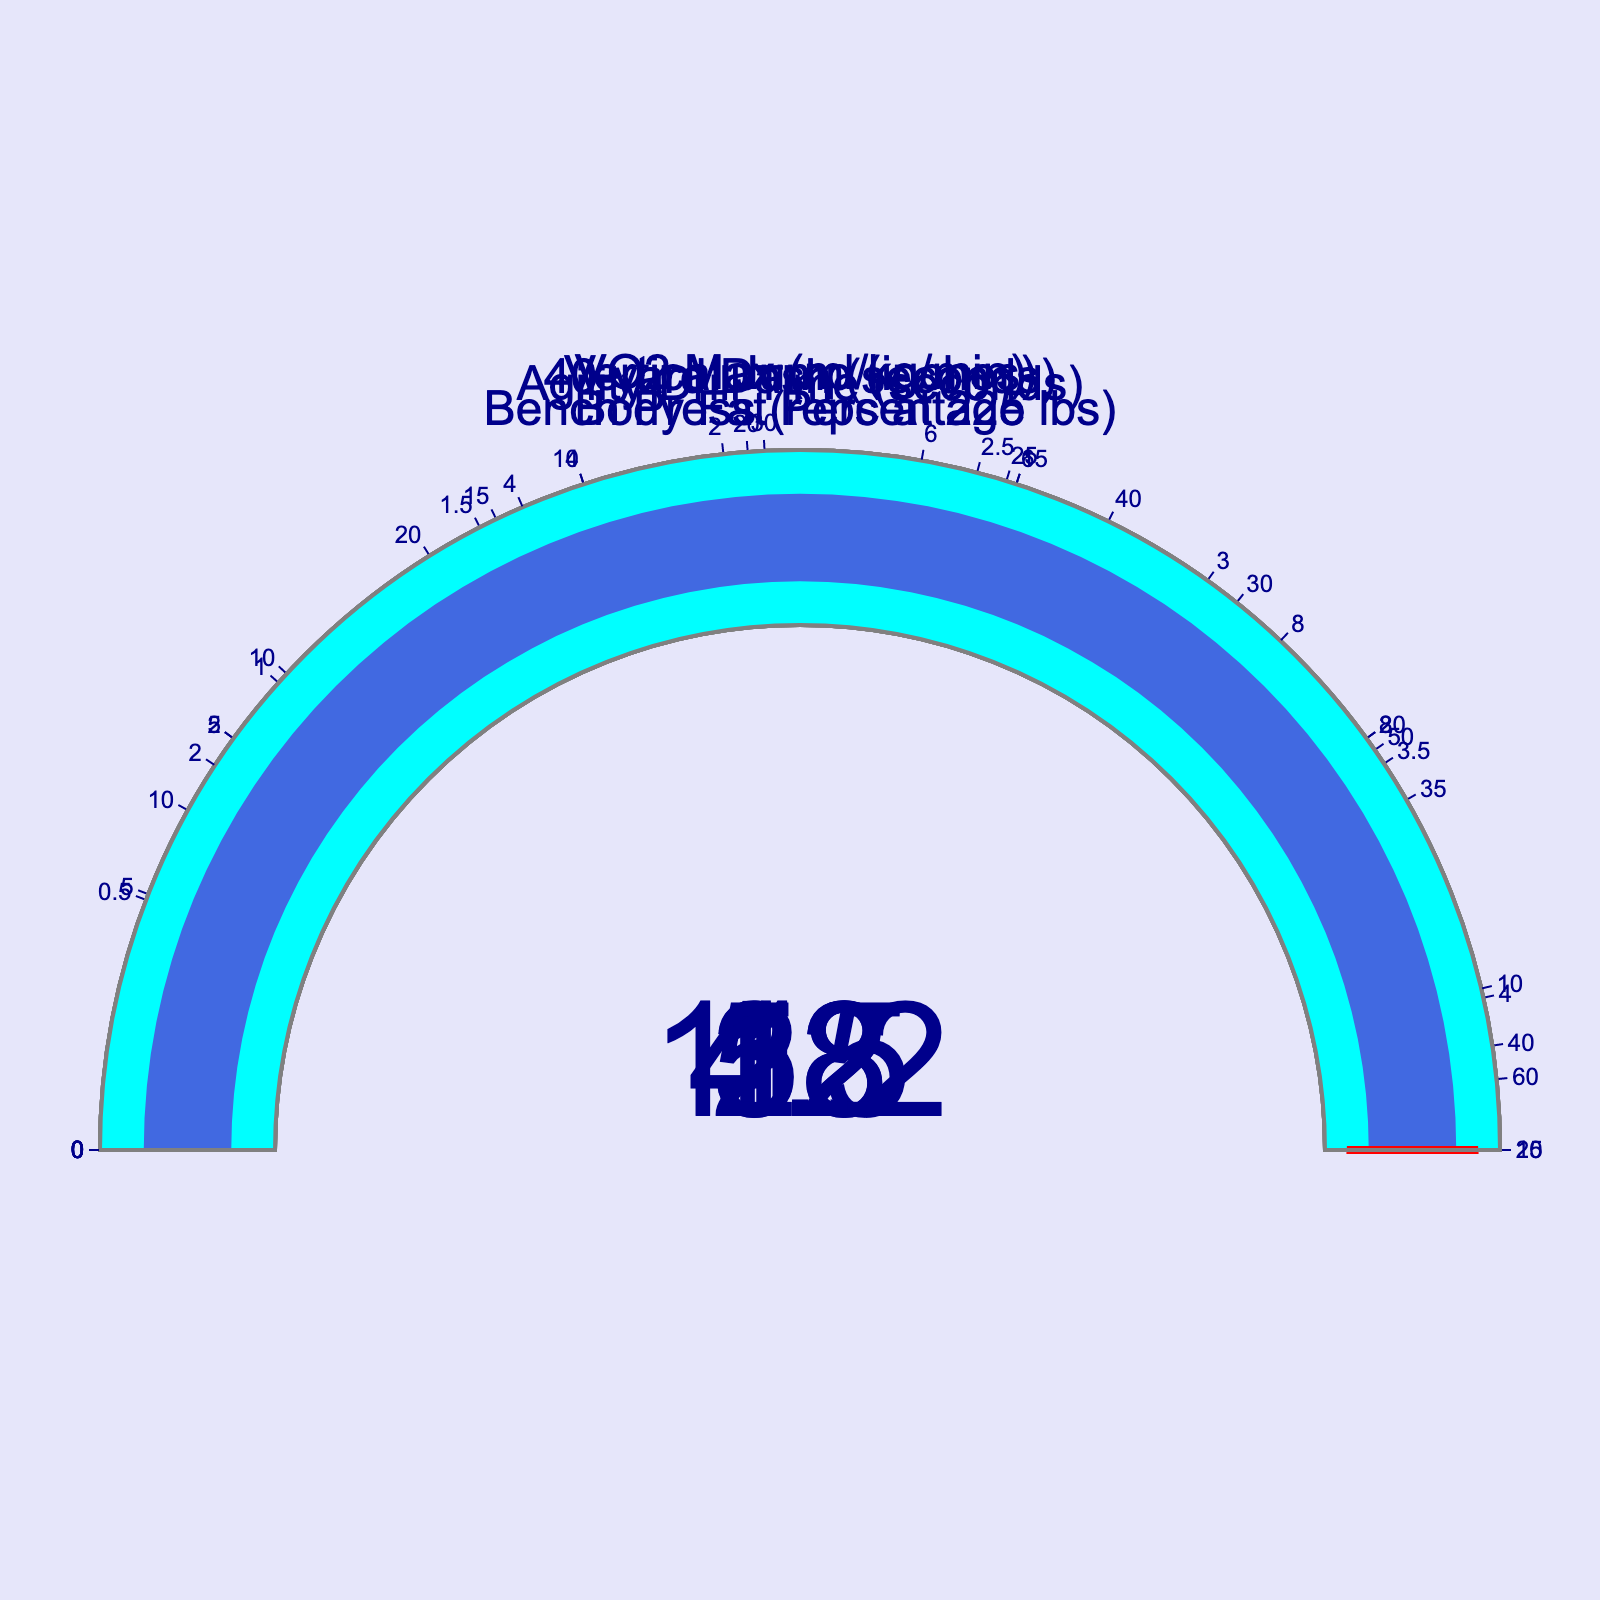What is the vertical jump value? The figure shows the vertical jump value as 38 inches on the gauge chart.
Answer: 38 inches By how much does the current vertical jump fall short of the personal best? The current vertical jump value is 38 inches, and the personal best (maximum value) is 42 inches. Therefore, the difference is 42 - 38 = 4 inches.
Answer: 4 inches What is the current value of the Bench Press metric? The gauge chart shows the Bench Press metric has a current value of 22 reps.
Answer: 22 reps Is the Body Fat Percentage above or below the personal best level? The current Body Fat Percentage is 12%, while the personal best (maximum value) is 10%. Since 12% is greater than 10%, the Body Fat Percentage is above the personal best level.
Answer: Above What is the gap between the current VO2 Max level and the personal best? The current VO2 Max level is 58 ml/kg/min, and the personal best is 62 ml/kg/min. The difference is 62 - 58 = 4 ml/kg/min.
Answer: 4 ml/kg/min What is the current value for the Agility Drill Time metric? The current value for the Agility Drill Time metric is shown on the gauge chart as 11.2 seconds.
Answer: 11.2 seconds 